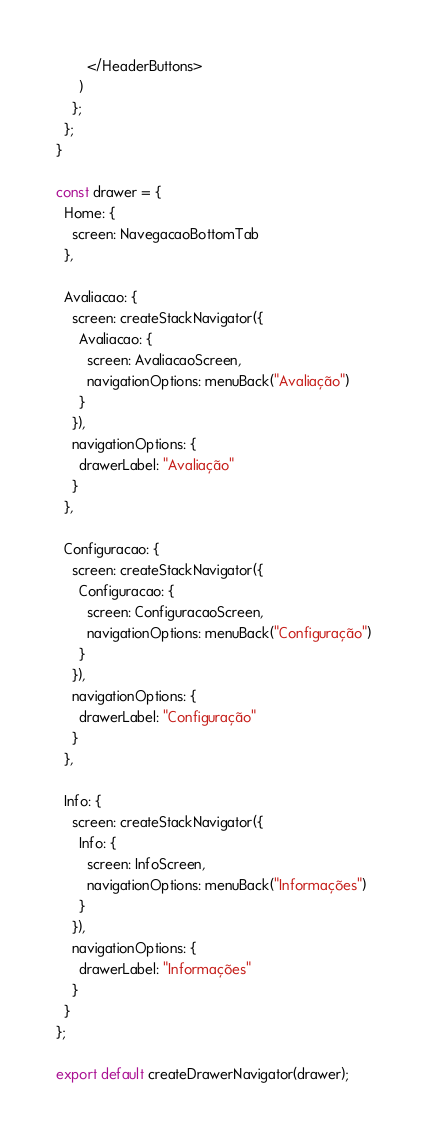Convert code to text. <code><loc_0><loc_0><loc_500><loc_500><_JavaScript_>        </HeaderButtons>
      )
    };
  };
}

const drawer = {
  Home: {
    screen: NavegacaoBottomTab
  },

  Avaliacao: {
    screen: createStackNavigator({
      Avaliacao: {
        screen: AvaliacaoScreen,
        navigationOptions: menuBack("Avaliação")
      }
    }),
    navigationOptions: {
      drawerLabel: "Avaliação"
    }
  },

  Configuracao: {
    screen: createStackNavigator({
      Configuracao: {
        screen: ConfiguracaoScreen,
        navigationOptions: menuBack("Configuração")
      }
    }),
    navigationOptions: {
      drawerLabel: "Configuração"
    }
  },

  Info: {
    screen: createStackNavigator({
      Info: {
        screen: InfoScreen,
        navigationOptions: menuBack("Informações")
      }
    }),
    navigationOptions: {
      drawerLabel: "Informações"
    }
  }
};

export default createDrawerNavigator(drawer);
</code> 